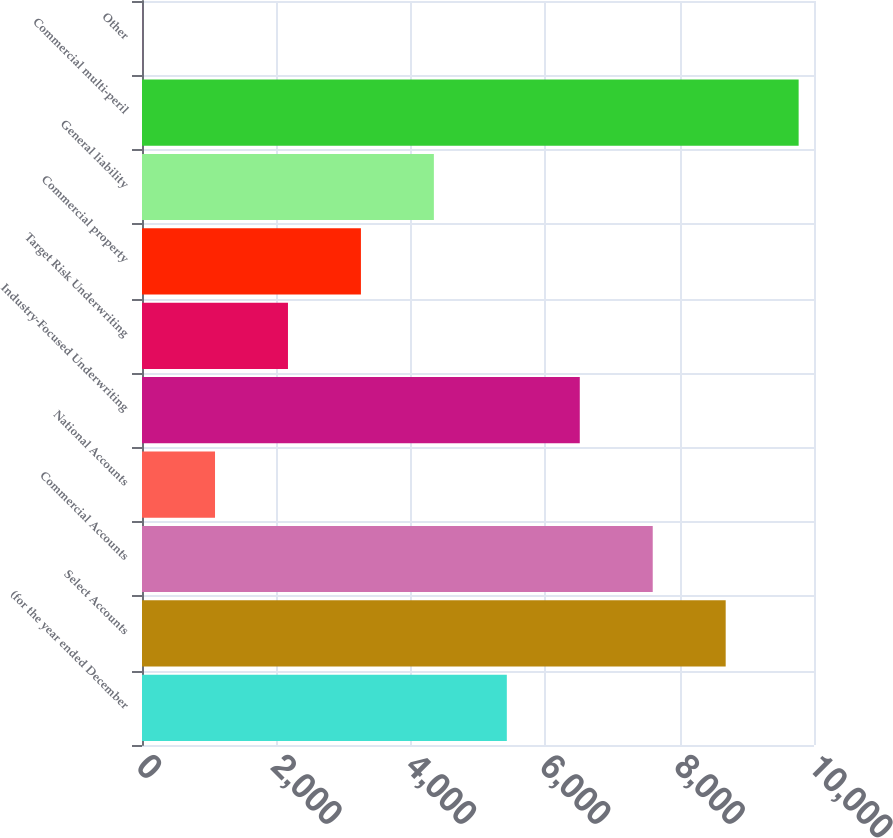<chart> <loc_0><loc_0><loc_500><loc_500><bar_chart><fcel>(for the year ended December<fcel>Select Accounts<fcel>Commercial Accounts<fcel>National Accounts<fcel>Industry-Focused Underwriting<fcel>Target Risk Underwriting<fcel>Commercial property<fcel>General liability<fcel>Commercial multi-peril<fcel>Other<nl><fcel>5429<fcel>8685.8<fcel>7600.2<fcel>1086.6<fcel>6514.6<fcel>2172.2<fcel>3257.8<fcel>4343.4<fcel>9771.4<fcel>1<nl></chart> 